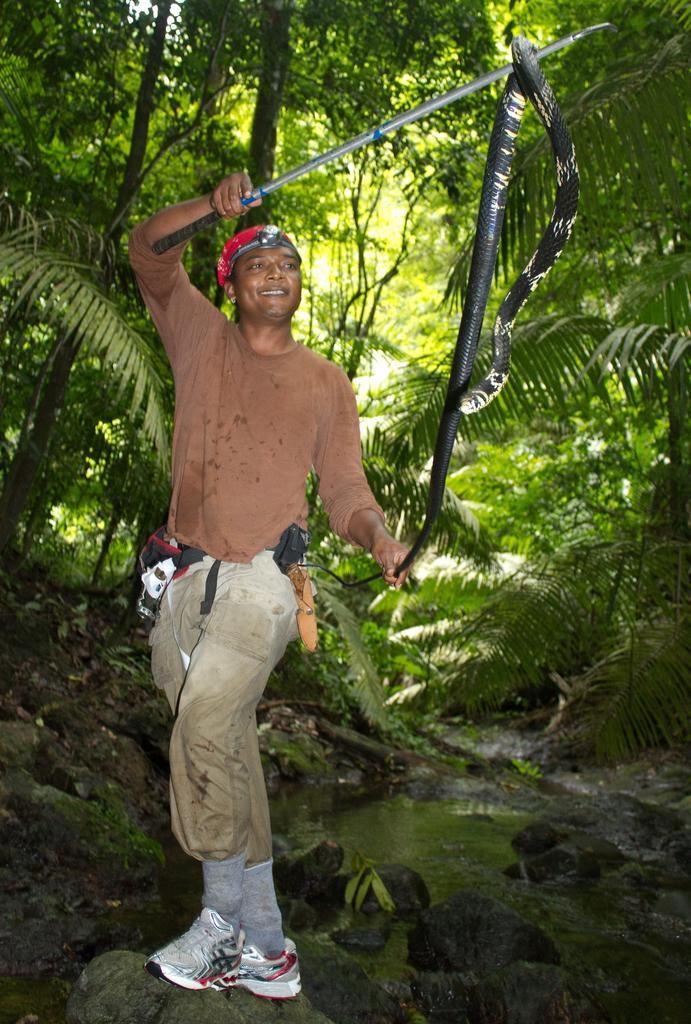In one or two sentences, can you explain what this image depicts? In the picture I can see a person wearing brown color T-shirt, socks and shoes is holding a stick and a snake in his hands and standing on the rocks. Here we can see the water and rocks and the trees in the background. 